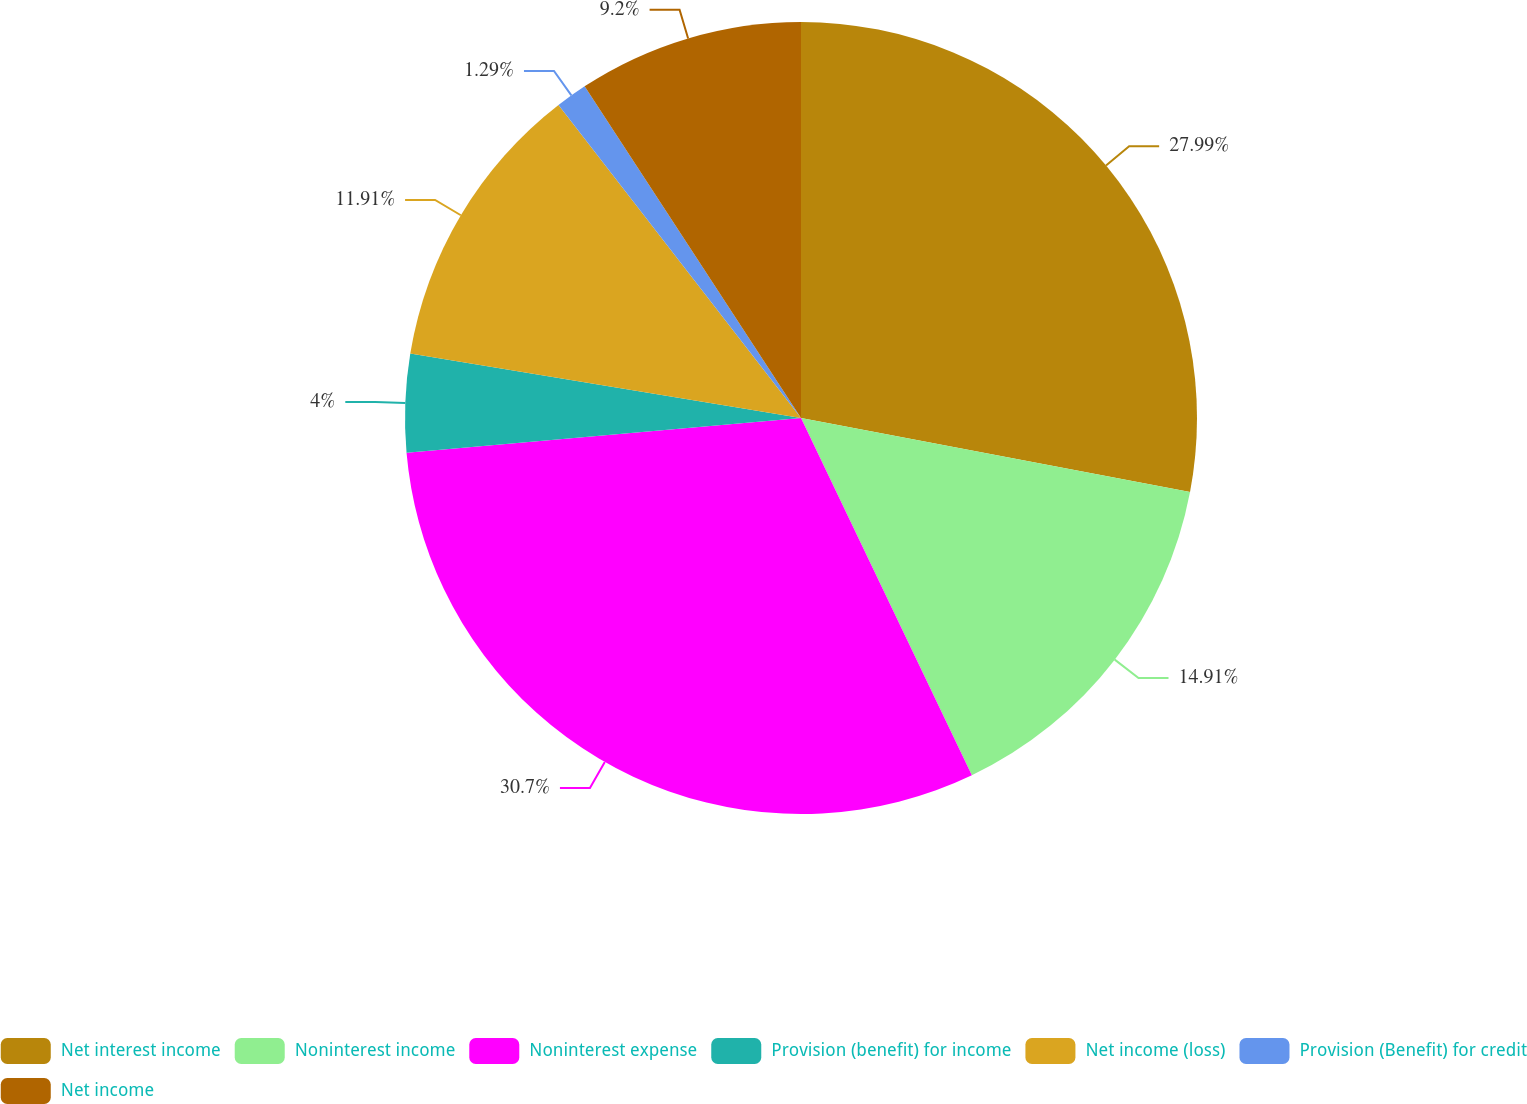Convert chart. <chart><loc_0><loc_0><loc_500><loc_500><pie_chart><fcel>Net interest income<fcel>Noninterest income<fcel>Noninterest expense<fcel>Provision (benefit) for income<fcel>Net income (loss)<fcel>Provision (Benefit) for credit<fcel>Net income<nl><fcel>27.99%<fcel>14.91%<fcel>30.7%<fcel>4.0%<fcel>11.91%<fcel>1.29%<fcel>9.2%<nl></chart> 